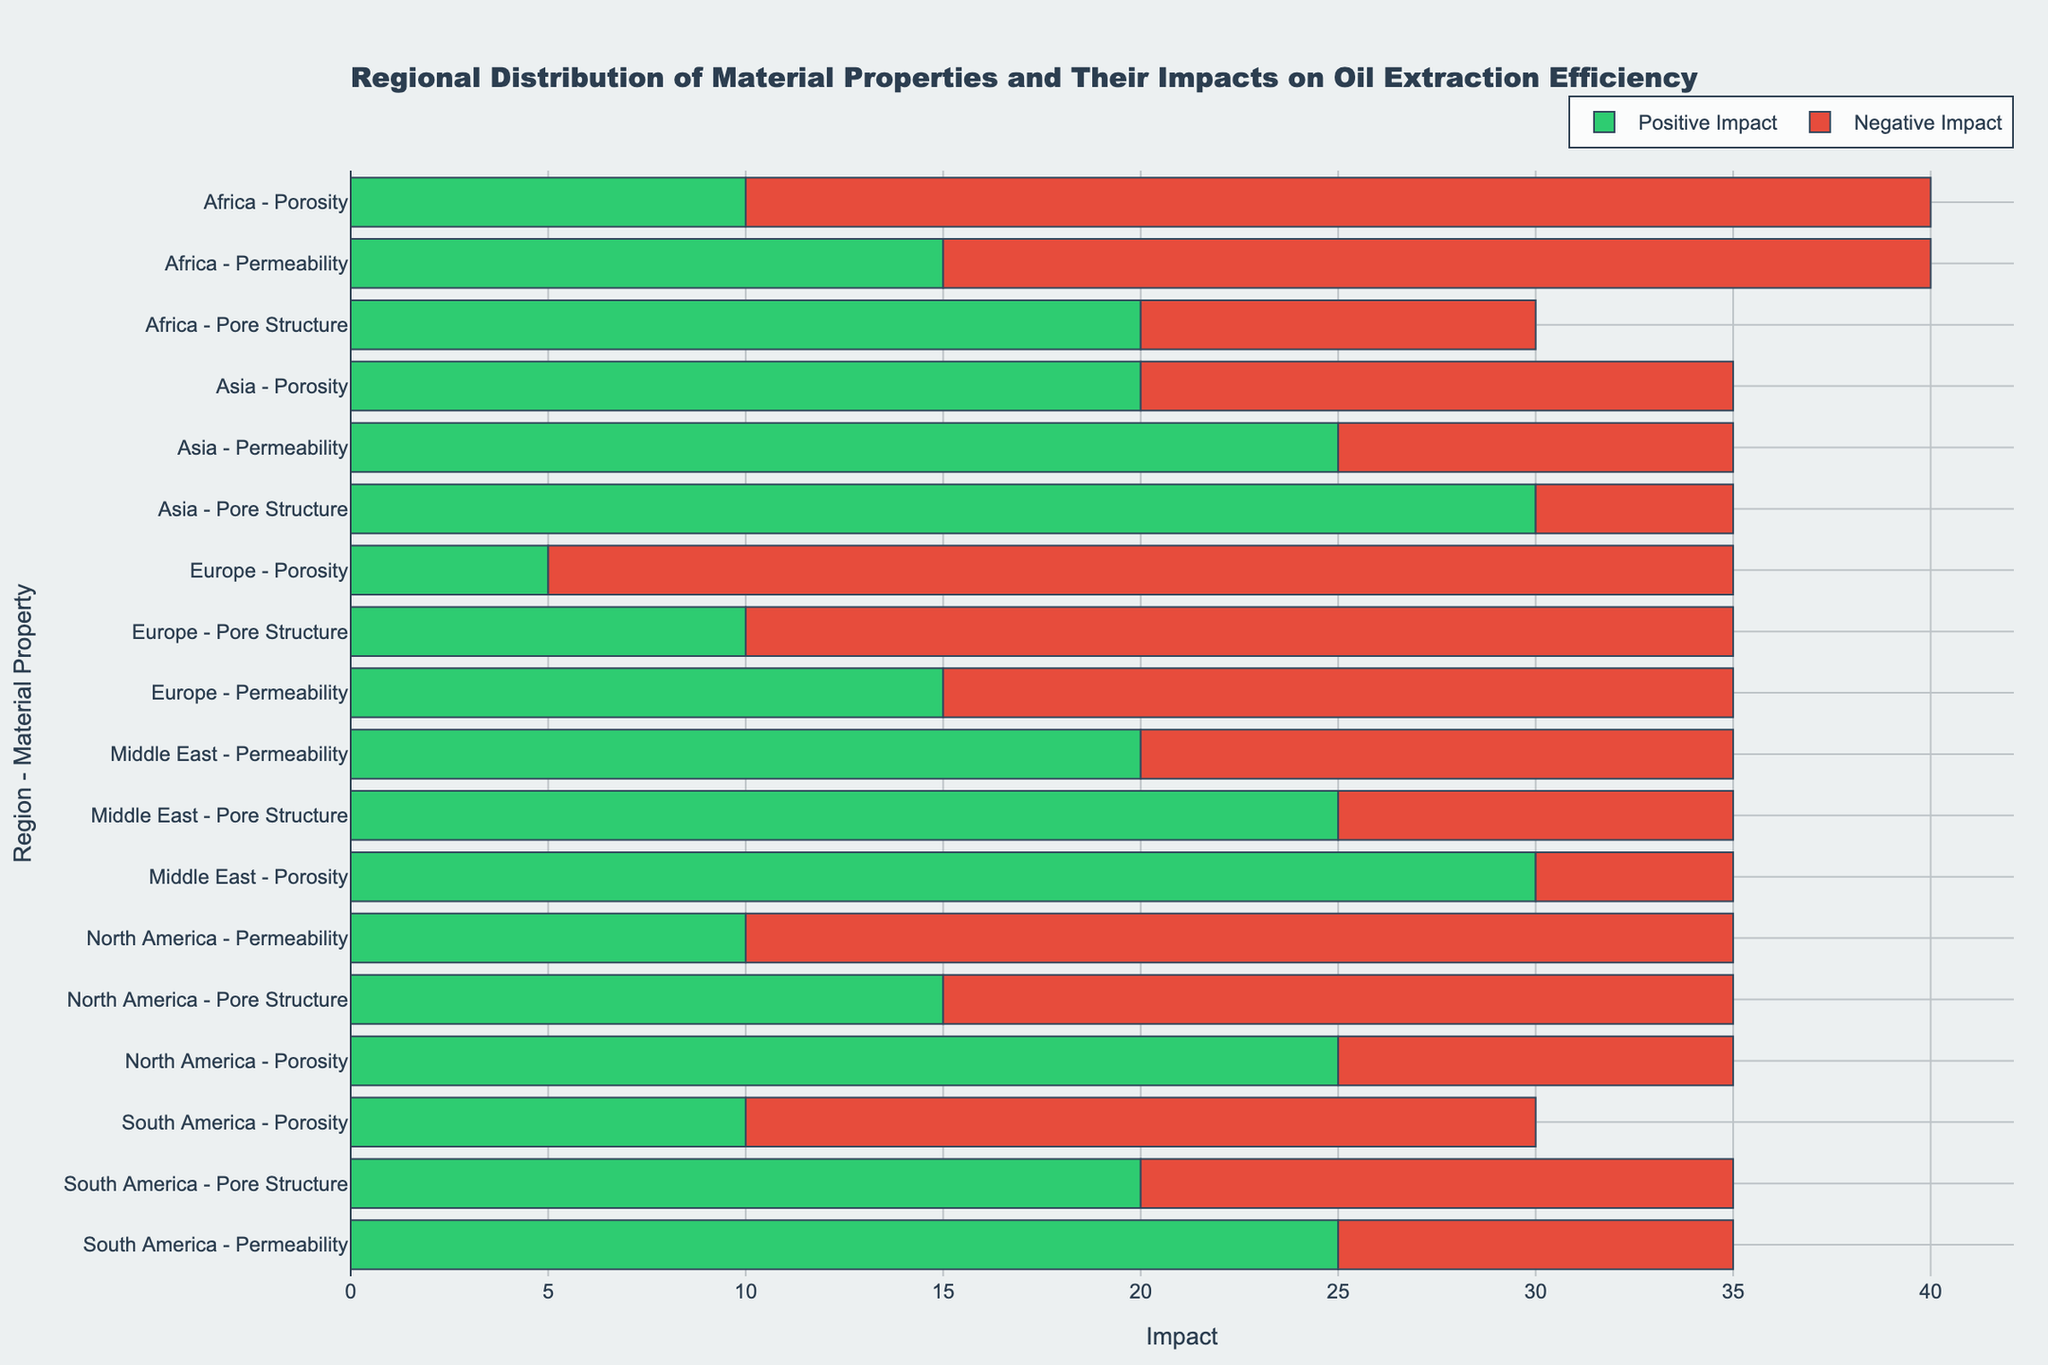What region shows the highest positive impact for permeability? To find the highest positive impact for permeability, look at the green bars labeled permeability for each region. Asia has the highest value with a positive impact of 25.
Answer: Asia Which material property in Europe has the greatest negative impact? To identify this, observe the red bars in the Europe region. Porosity has the largest negative impact with a value of 30.
Answer: Porosity Compare the net impact for porosity between North America and Africa. Which region has a higher net impact? Calculate net impact for porosity (positive impact - negative impact) for both regions. North America: 25 - 10 = 15. Africa: 10 - 30 = -20. North America has a higher net impact.
Answer: North America Is the positive impact for pore structure in Middle East greater than that for Europe? Compare the lengths of the green bars for pore structure in Middle East and Europe. The Middle East has a positive impact of 25, while Europe has a positive impact of 10.
Answer: Yes What is the average net impact of permeability in all regions? First, calculate the net impact for permeability in each region: Middle East: 20 - 15 = 5, North America: 10 - 25 = -15, South America: 25 - 10 = 15, Europe: 15 - 20 = -5, Asia: 25 - 10 = 15, Africa: 15 - 25 = -10. Then find the average: (5 + -15 + 15 + -5 + 15 + -10) / 6 = 5/6 ≈ 0.83
Answer: 0.83 Which region has the smallest standard deviation in the positive impacts across all material properties? Calculate the standard deviation for the positive impacts across all material properties for each region. The region with the smallest deviation is the one with the least variability in their positive impact values. Middle East: std([25, 20, 30]), North America: std([15, 10, 25]), South America: std([20, 25, 10]), Europe: std([10, 15, 5]), Asia: std([30, 25, 20]), Africa: std([20, 15, 10]). Europe has the smallest deviation.
Answer: Europe How does the negative impact of permeability in Africa compare to the positive impact of pore structure in North America? Compare the lengths of the red bar for permeability in Africa (25) and the green bar for pore structure in North America (15).
Answer: Africa's negative impact is higher What is the total negative impact across all regions for porosity? Sum the negative impacts of porosity across all regions: Middle East: 5, North America: 10, South America: 20, Europe: 30, Asia: 15, Africa: 30. Total = 5 + 10 + 20 + 30 + 15 + 30 = 110
Answer: 110 Which region has the smallest combined impact (positive + negative) for pore structure? Add the positive and negative impacts for pore structure in each region. Middle East: 25 + 10 = 35, North America: 15 + 20 = 35, South America: 20 + 15 = 35, Europe: 10 + 25 = 35, Asia: 30 + 5 = 35, Africa: 20 + 10 = 30. Africa has the smallest combined impact.
Answer: Africa 